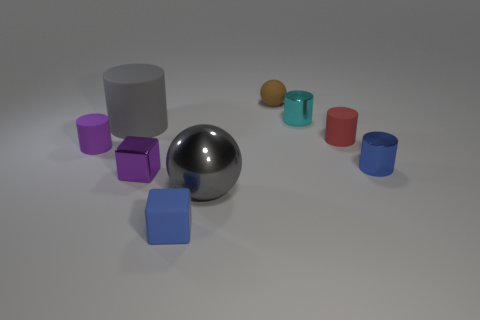There is a ball that is in front of the red matte cylinder; does it have the same size as the tiny matte sphere?
Ensure brevity in your answer.  No. Is the number of purple metallic things that are behind the large metallic object greater than the number of brown rubber balls?
Your answer should be very brief. No. Is the shape of the tiny purple rubber object the same as the tiny purple shiny thing?
Offer a very short reply. No. How big is the purple cylinder?
Ensure brevity in your answer.  Small. Is the number of tiny blocks in front of the purple metallic object greater than the number of gray rubber cylinders that are in front of the purple rubber cylinder?
Provide a succinct answer. Yes. There is a purple cylinder; are there any blue metallic things on the left side of it?
Your response must be concise. No. Are there any purple shiny things that have the same size as the metallic cube?
Your answer should be very brief. No. The tiny block that is made of the same material as the red thing is what color?
Provide a short and direct response. Blue. What is the large gray cylinder made of?
Make the answer very short. Rubber. What shape is the gray shiny object?
Offer a terse response. Sphere. 